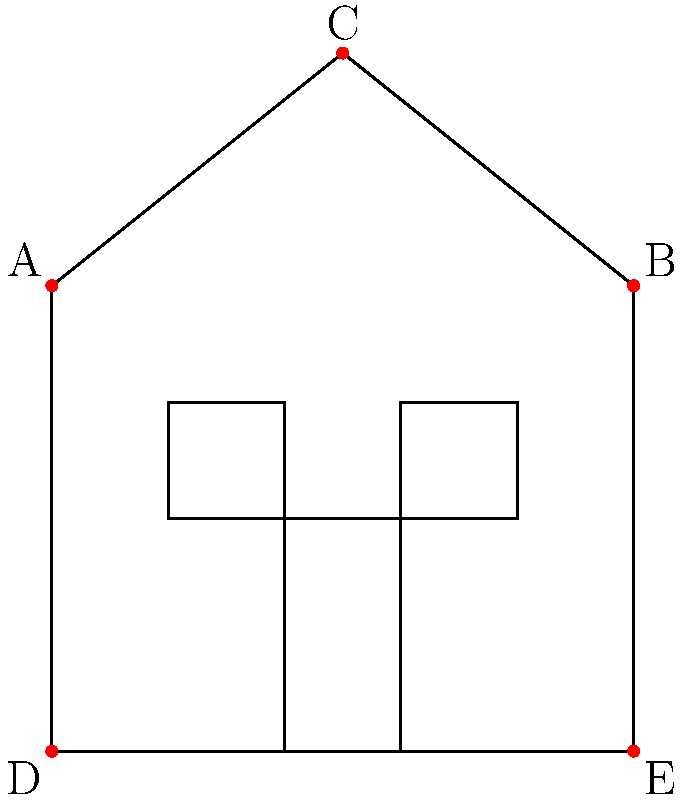As a safety-conscious resident of Mt. Olive, TN, you want to install security cameras around your house. Given the house layout shown, which combination of camera positions would provide the most comprehensive coverage of the exterior while using the fewest number of cameras? To determine the optimal placement of security cameras, we need to consider the following steps:

1. Analyze the house layout:
   - The house has two stories with a peaked roof.
   - There are two windows on the front and a central door.

2. Consider the coverage areas for each camera position:
   - A: Covers the left side and part of the front
   - B: Covers the right side and part of the front
   - C: Covers the roof and provides a bird's-eye view of the front
   - D: Covers the left corner and part of the front
   - E: Covers the right corner and part of the front

3. Evaluate combinations for maximum coverage with minimum cameras:
   - A + B: Covers sides but misses some of the front
   - A + B + C: Covers sides, front, and roof, but may miss corners
   - A + E: Covers left side, right corner, and most of the front
   - B + D: Covers right side, left corner, and most of the front

4. Determine the best combination:
   - A + E provides the most comprehensive coverage with just two cameras
   - This combination covers both sides, both front corners, and the entire front of the house

5. Consider the aesthetic appeal:
   - A + E is symmetrical, which maintains the house's aesthetic appeal

Therefore, the optimal placement for maximum coverage and minimum number of cameras is positions A and E.
Answer: A and E 